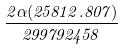<formula> <loc_0><loc_0><loc_500><loc_500>\frac { 2 \alpha ( 2 5 8 1 2 . 8 0 7 ) } { 2 9 9 7 9 2 4 5 8 }</formula> 